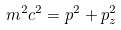<formula> <loc_0><loc_0><loc_500><loc_500>m ^ { 2 } c ^ { 2 } = p ^ { 2 } + p _ { z } ^ { 2 }</formula> 